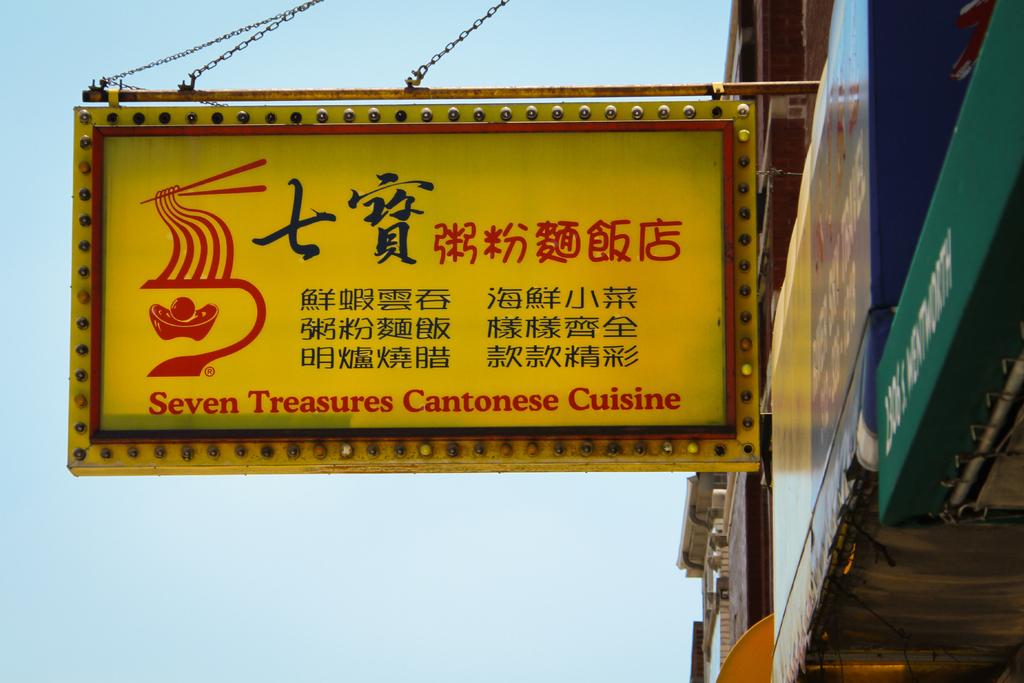What language is in the writings?
Provide a short and direct response. Cantonese. 